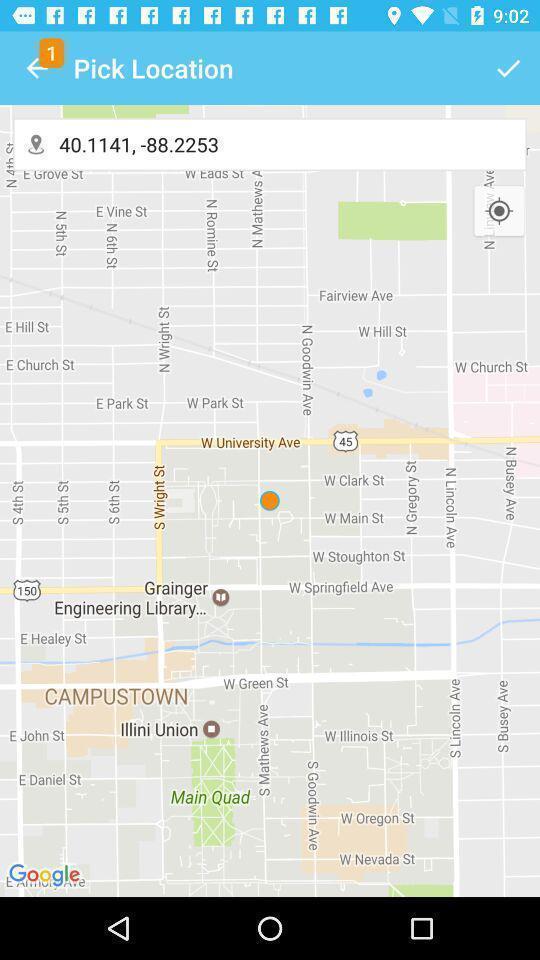Describe this image in words. Screen displaying map. 